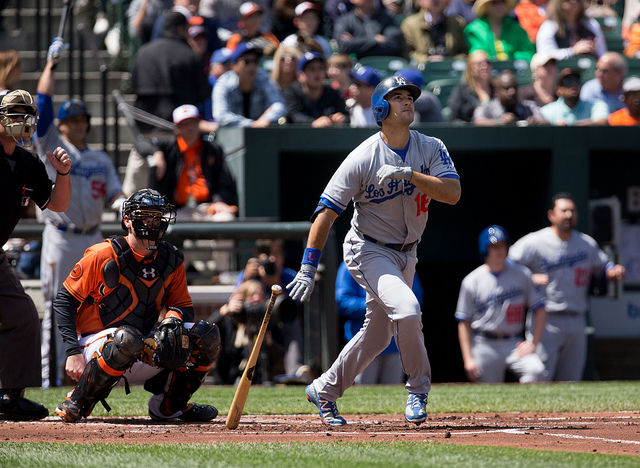<image>Did the batter strike out? It's unknown whether the batter struck out or not. Did the batter strike out? It is unknown if the batter struck out. It is possible that they did not. 